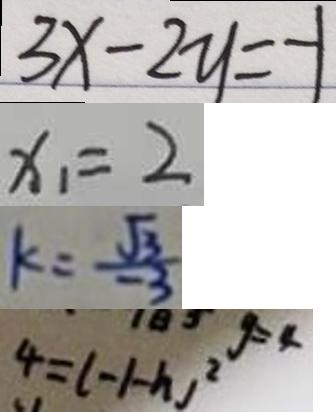Convert formula to latex. <formula><loc_0><loc_0><loc_500><loc_500>3 x - 2 y = - 1 
 x _ { 1 } = 2 
 k = \frac { \sqrt { 3 } } { - 3 } 
 4 = ( - 1 - h ) ^ { 2 }</formula> 